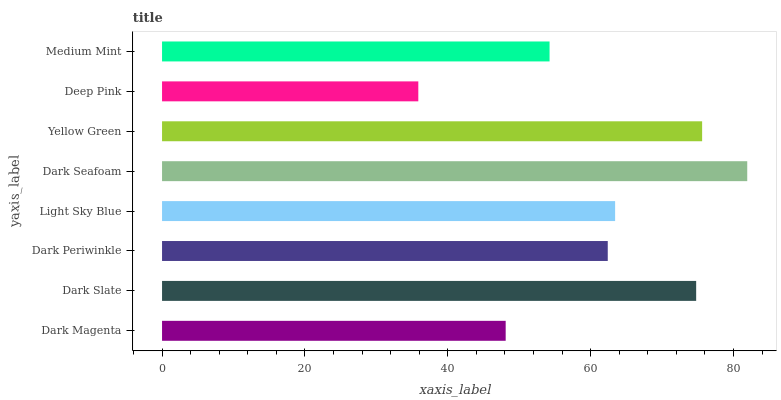Is Deep Pink the minimum?
Answer yes or no. Yes. Is Dark Seafoam the maximum?
Answer yes or no. Yes. Is Dark Slate the minimum?
Answer yes or no. No. Is Dark Slate the maximum?
Answer yes or no. No. Is Dark Slate greater than Dark Magenta?
Answer yes or no. Yes. Is Dark Magenta less than Dark Slate?
Answer yes or no. Yes. Is Dark Magenta greater than Dark Slate?
Answer yes or no. No. Is Dark Slate less than Dark Magenta?
Answer yes or no. No. Is Light Sky Blue the high median?
Answer yes or no. Yes. Is Dark Periwinkle the low median?
Answer yes or no. Yes. Is Dark Slate the high median?
Answer yes or no. No. Is Yellow Green the low median?
Answer yes or no. No. 